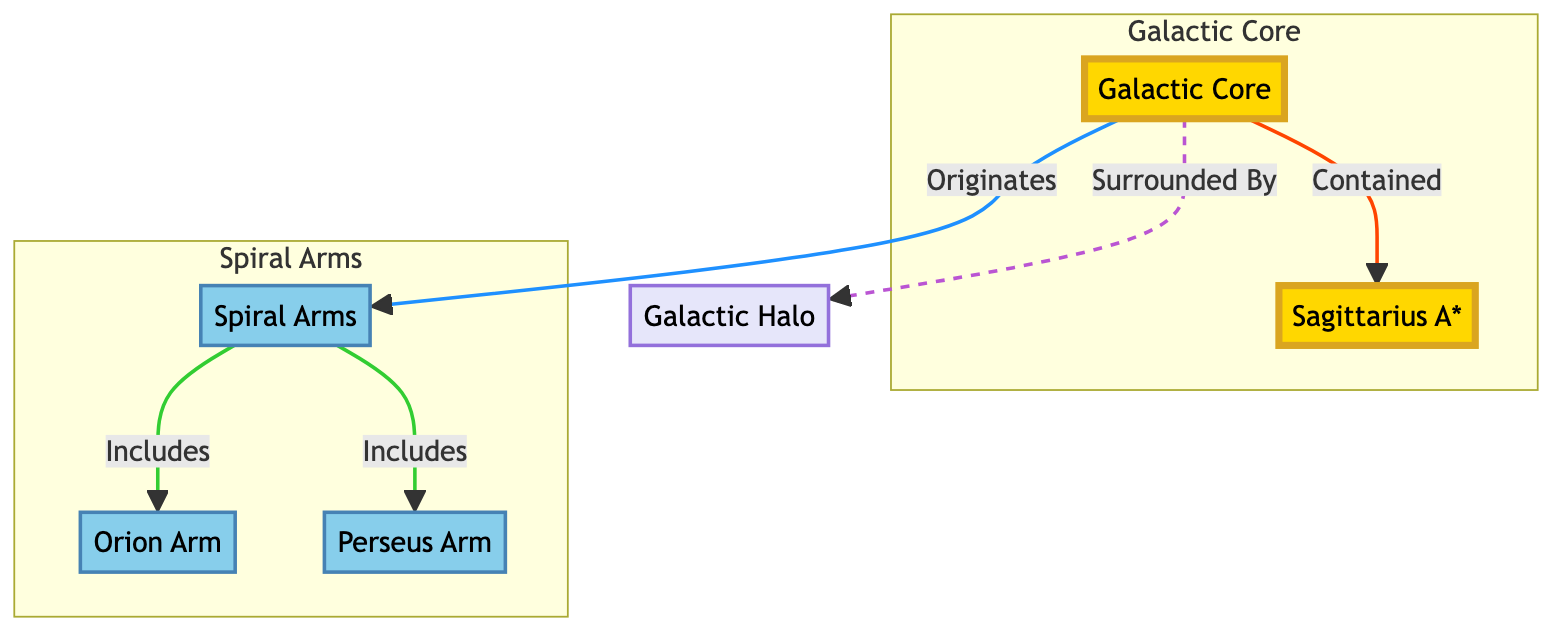What is the primary component at the center of the diagram? The center of the diagram is labeled as "Galactic Core," which specifically contains the node "Sagittarius A*." Thus, the primary component located at the center is Sagittarius A*.
Answer: Sagittarius A* How many spiral arms are depicted in the diagram? There are three specific spiral arms mentioned in the diagram: "Spiral Arms," "Orion Arm," and "Perseus Arm." Therefore, the total number of spiral arms is three.
Answer: 3 What color represents the galactic core in the diagram? The galactic core is represented by the color that visually appears as gold, indicated by the class definition for core. Hence, the color for the galactic core is gold.
Answer: Gold Which component is surrounded by the galactic halo? The diagram indicates that the "Galactic Core" is surrounded by the "Galactic Halo," represented by a dashed line connection. Therefore, the component surrounded by the galactic halo is the Galactic Core.
Answer: Galactic Core What two arms are included in the spiral arms? The spiral arms include the "Orion Arm" and the "Perseus Arm," both of which are directly connected under the "Spiral Arms." Thus, the two included arms are Orion Arm and Perseus Arm.
Answer: Orion Arm, Perseus Arm Which relationship is indicated between the galactic core and the spiral arms? The diagram states that the spiral arms "Originates" from the galactic core, indicating a direct connection of outflow from the core to the arms. Hence, the relationship indicated is that the spiral arms originate from the galactic core.
Answer: Originates What type of visual structure is represented in this diagram? The structure represented is a flowchart that visually depicts relationships among different components of the Milky Way’s structure, including somes nodes and connecting lines. Therefore, the type of visual structure is a flowchart.
Answer: Flowchart How does the galactic core relate to Sagittarius A*? The diagram illustrates that the "Galactic Core" is "Contained" by "Sagittarius A*," inferring that the core's existence relies on or is encapsulated within this specific part. Thus, the relationship is containment.
Answer: Contained 